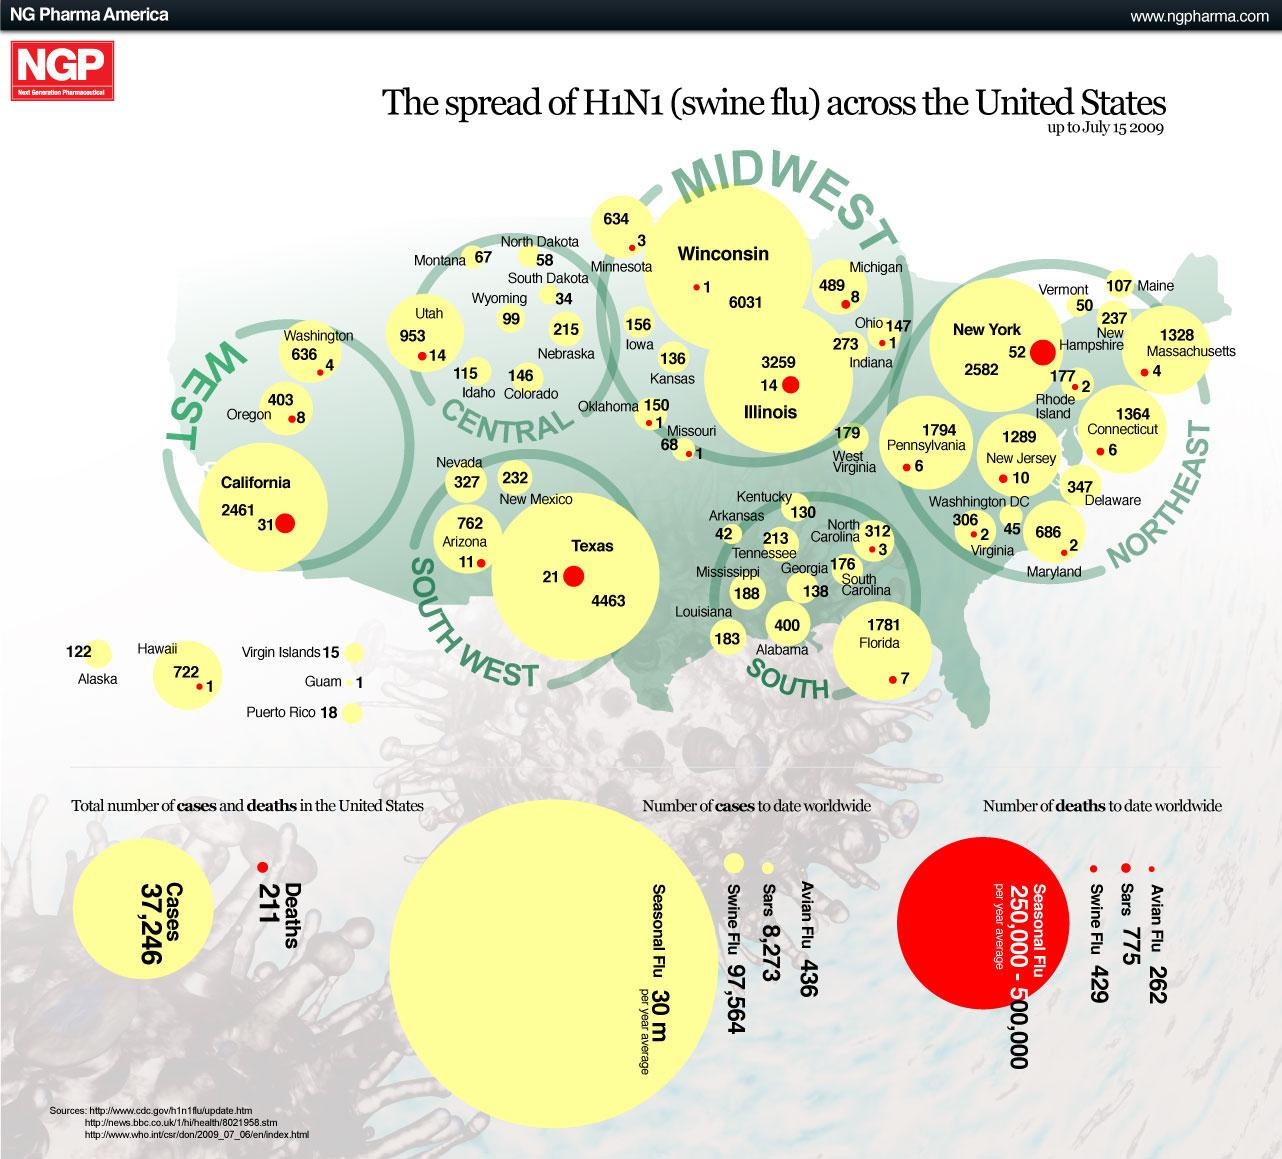List a handful of essential elements in this visual. The total number of death cases reported in all states in the Southern region is 10. In Georgia, 138 cases of Swine Flu were reported. The state in the Southwest region with the highest number of H1N1 cases is Texas. Illinois reported 3,259 cases of H1N1 flu. The highest number of deaths due to Swine Flu was reported in New York state. 